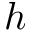Convert formula to latex. <formula><loc_0><loc_0><loc_500><loc_500>h</formula> 